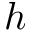Convert formula to latex. <formula><loc_0><loc_0><loc_500><loc_500>h</formula> 